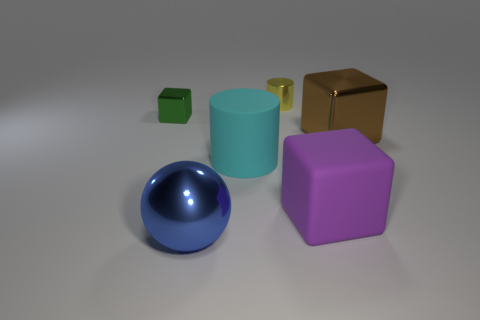Add 1 cyan matte things. How many objects exist? 7 Subtract all spheres. How many objects are left? 5 Subtract all big blue metallic cubes. Subtract all large cylinders. How many objects are left? 5 Add 3 large brown metallic things. How many large brown metallic things are left? 4 Add 5 big matte blocks. How many big matte blocks exist? 6 Subtract 1 cyan cylinders. How many objects are left? 5 